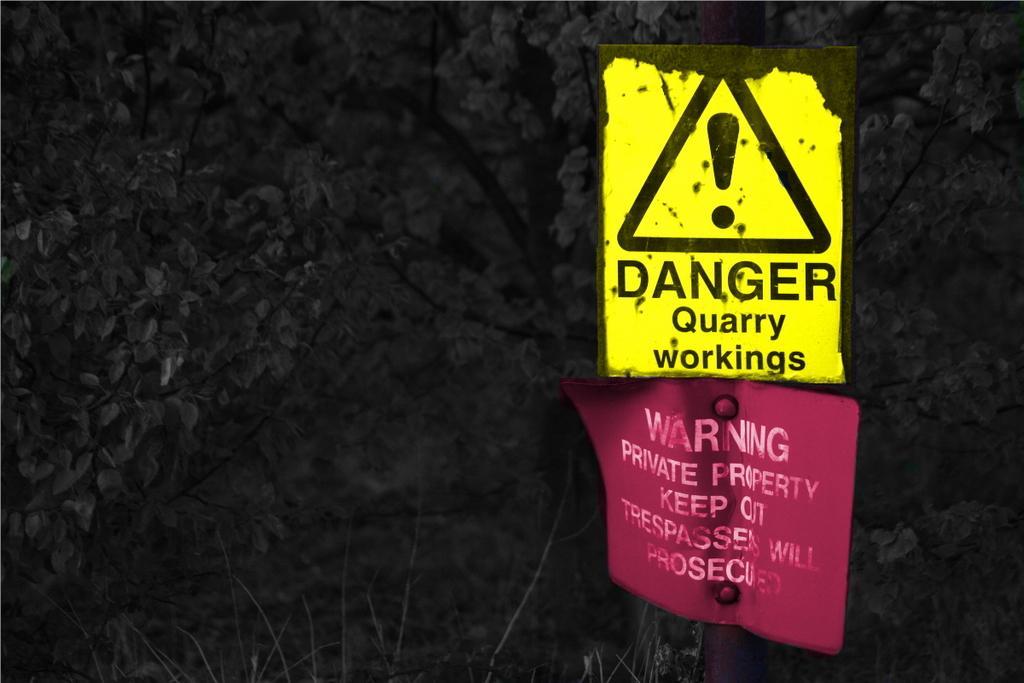Please provide a concise description of this image. In this image, we can see a pole with yellow and pink caution boards. At the bottom we can see the grass. In the background, we can see dark and trees. 